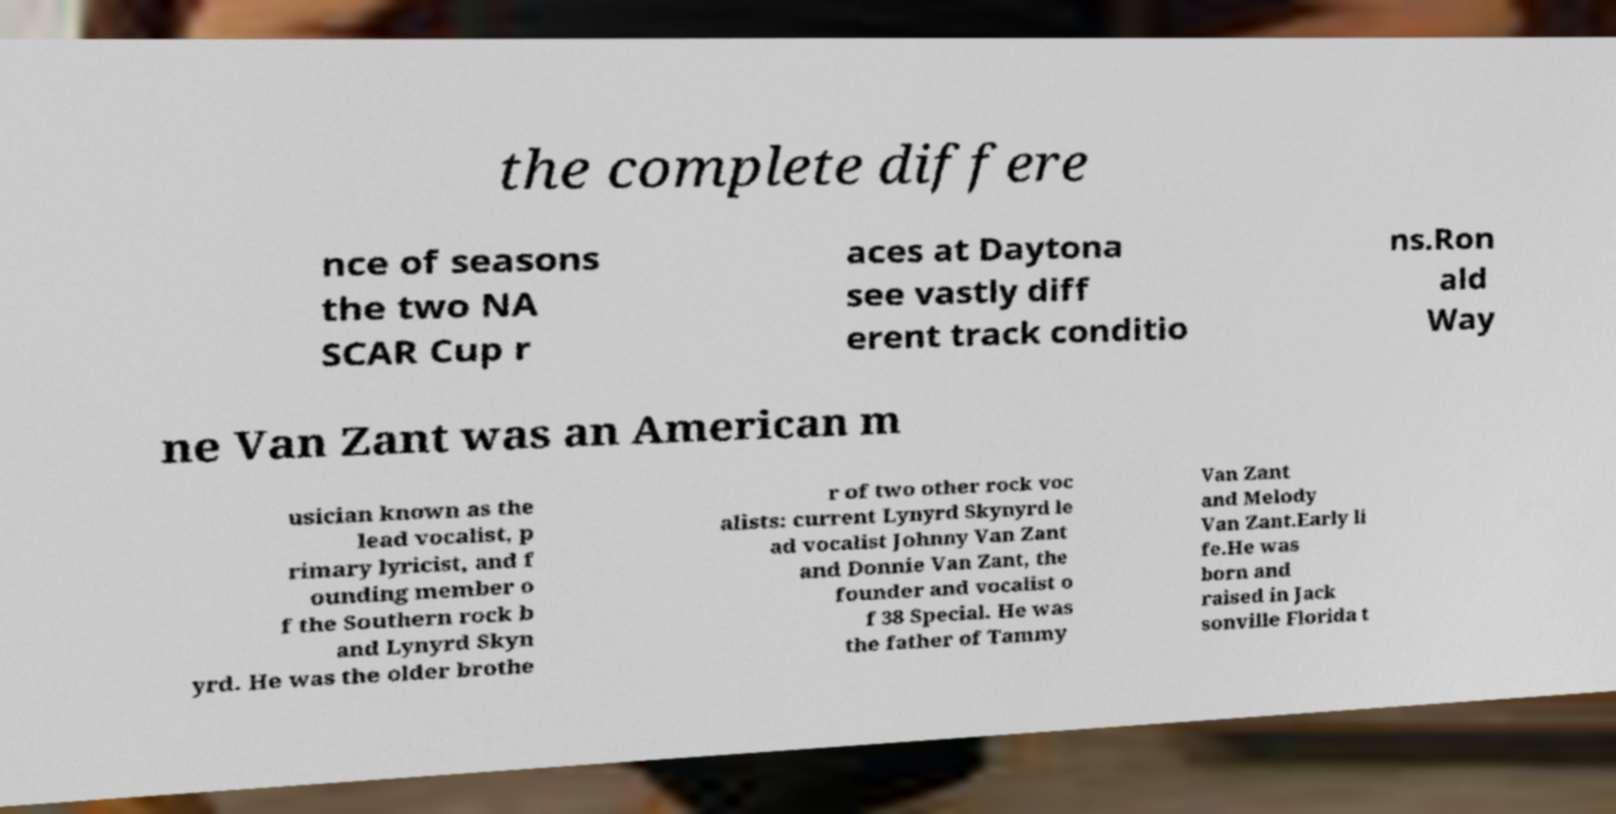Can you read and provide the text displayed in the image?This photo seems to have some interesting text. Can you extract and type it out for me? the complete differe nce of seasons the two NA SCAR Cup r aces at Daytona see vastly diff erent track conditio ns.Ron ald Way ne Van Zant was an American m usician known as the lead vocalist, p rimary lyricist, and f ounding member o f the Southern rock b and Lynyrd Skyn yrd. He was the older brothe r of two other rock voc alists: current Lynyrd Skynyrd le ad vocalist Johnny Van Zant and Donnie Van Zant, the founder and vocalist o f 38 Special. He was the father of Tammy Van Zant and Melody Van Zant.Early li fe.He was born and raised in Jack sonville Florida t 